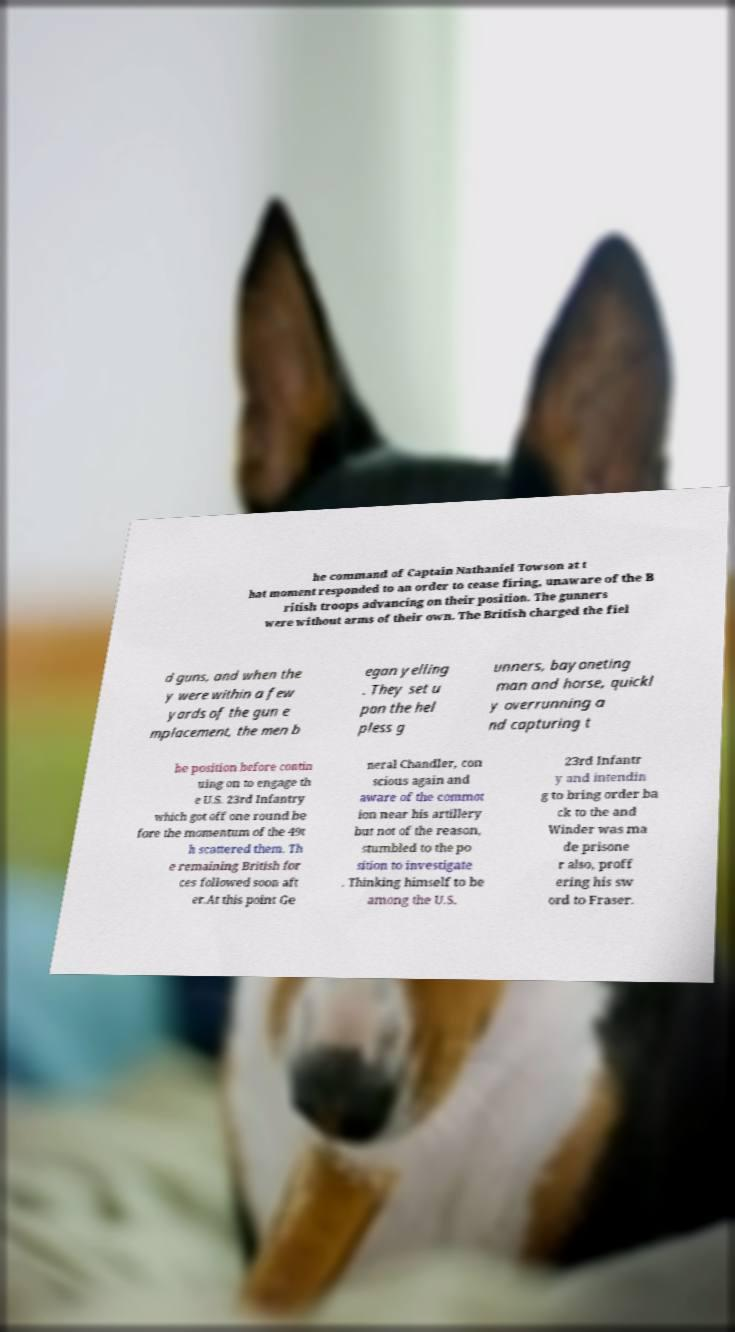For documentation purposes, I need the text within this image transcribed. Could you provide that? he command of Captain Nathaniel Towson at t hat moment responded to an order to cease firing, unaware of the B ritish troops advancing on their position. The gunners were without arms of their own. The British charged the fiel d guns, and when the y were within a few yards of the gun e mplacement, the men b egan yelling . They set u pon the hel pless g unners, bayoneting man and horse, quickl y overrunning a nd capturing t he position before contin uing on to engage th e U.S. 23rd Infantry which got off one round be fore the momentum of the 49t h scattered them. Th e remaining British for ces followed soon aft er.At this point Ge neral Chandler, con scious again and aware of the commot ion near his artillery but not of the reason, stumbled to the po sition to investigate . Thinking himself to be among the U.S. 23rd Infantr y and intendin g to bring order ba ck to the and Winder was ma de prisone r also, proff ering his sw ord to Fraser. 